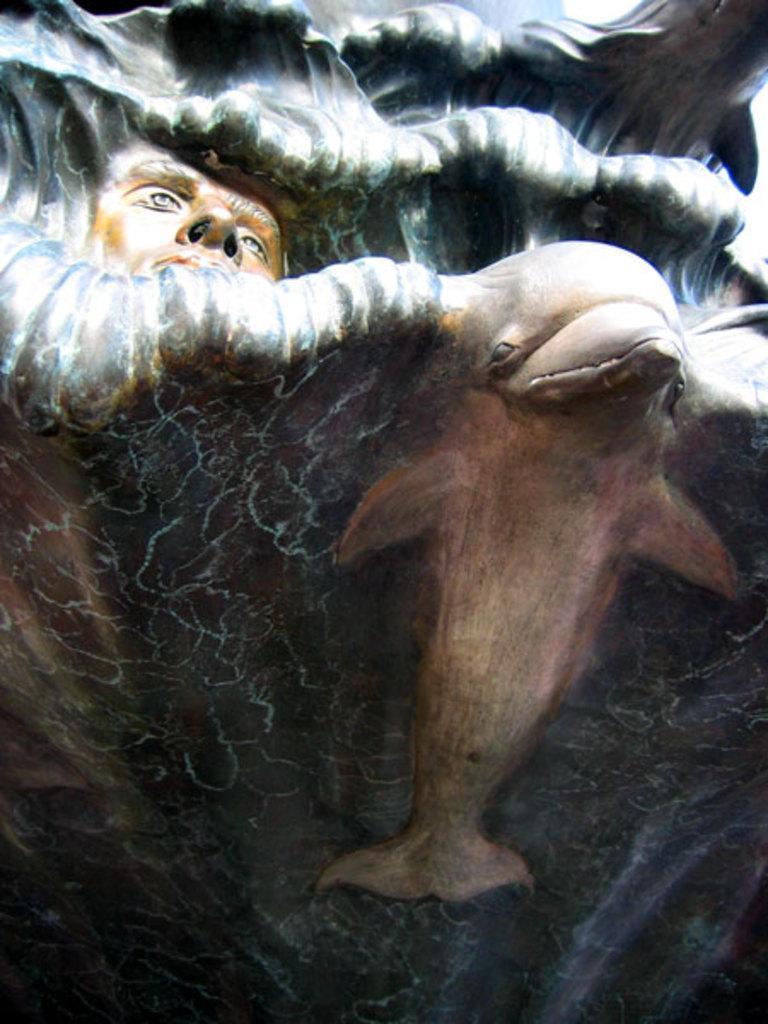How would you summarize this image in a sentence or two? In the image we can see some painting. 